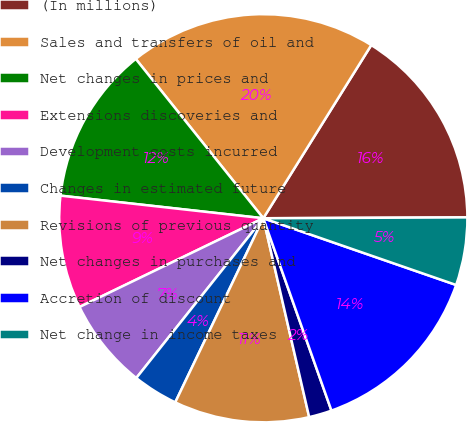Convert chart. <chart><loc_0><loc_0><loc_500><loc_500><pie_chart><fcel>(In millions)<fcel>Sales and transfers of oil and<fcel>Net changes in prices and<fcel>Extensions discoveries and<fcel>Development costs incurred<fcel>Changes in estimated future<fcel>Revisions of previous quantity<fcel>Net changes in purchases and<fcel>Accretion of discount<fcel>Net change in income taxes<nl><fcel>16.06%<fcel>19.62%<fcel>12.49%<fcel>8.93%<fcel>7.15%<fcel>3.59%<fcel>10.71%<fcel>1.81%<fcel>14.28%<fcel>5.37%<nl></chart> 